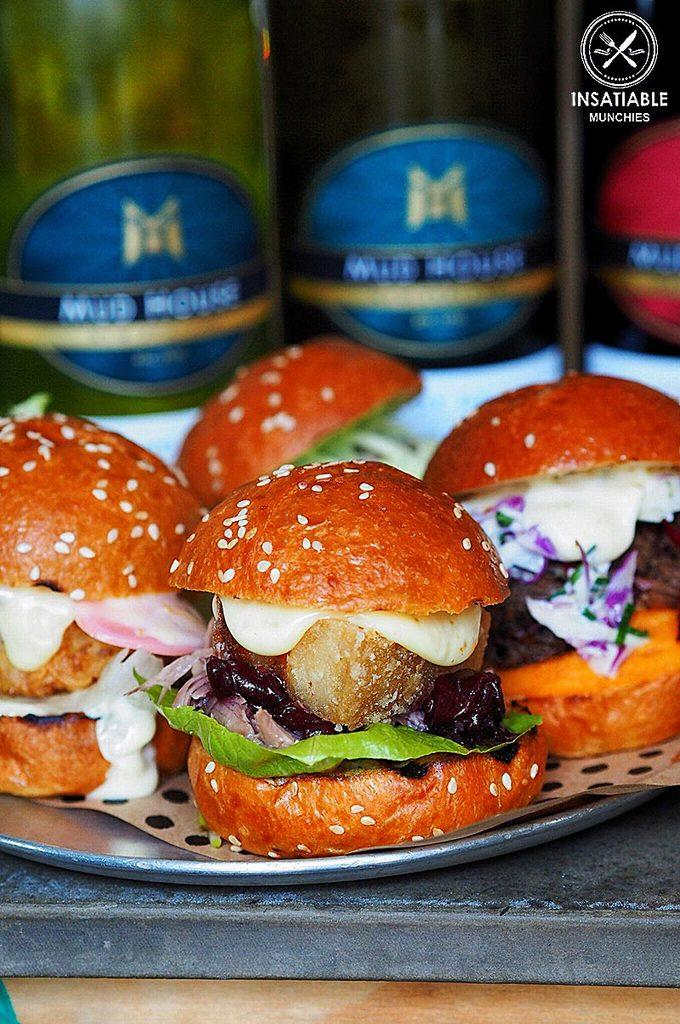What type of food is in the plate in the image? There are burgers in a plate in the image. Where is the plate located? The plate is placed on a surface. What else can be seen in the image besides the plate of burgers? There are bottles visible on the backside, and there is some text present. What type of scissors are being used to cut the burgers in the image? There are no scissors present in the image, and the burgers are not being cut. 